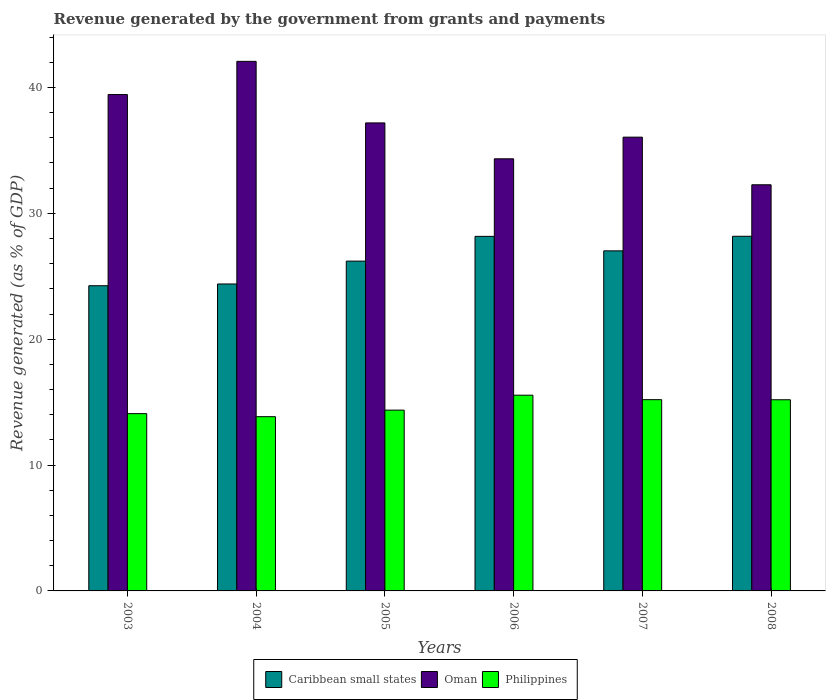How many groups of bars are there?
Offer a very short reply. 6. In how many cases, is the number of bars for a given year not equal to the number of legend labels?
Provide a short and direct response. 0. What is the revenue generated by the government in Philippines in 2003?
Your answer should be very brief. 14.09. Across all years, what is the maximum revenue generated by the government in Philippines?
Your response must be concise. 15.55. Across all years, what is the minimum revenue generated by the government in Philippines?
Ensure brevity in your answer.  13.84. What is the total revenue generated by the government in Philippines in the graph?
Your answer should be very brief. 88.23. What is the difference between the revenue generated by the government in Philippines in 2005 and that in 2008?
Give a very brief answer. -0.82. What is the difference between the revenue generated by the government in Oman in 2007 and the revenue generated by the government in Caribbean small states in 2004?
Offer a terse response. 11.67. What is the average revenue generated by the government in Oman per year?
Offer a terse response. 36.89. In the year 2006, what is the difference between the revenue generated by the government in Caribbean small states and revenue generated by the government in Philippines?
Offer a terse response. 12.62. In how many years, is the revenue generated by the government in Caribbean small states greater than 8 %?
Provide a succinct answer. 6. What is the ratio of the revenue generated by the government in Caribbean small states in 2004 to that in 2008?
Provide a short and direct response. 0.87. Is the revenue generated by the government in Philippines in 2003 less than that in 2008?
Make the answer very short. Yes. What is the difference between the highest and the second highest revenue generated by the government in Philippines?
Ensure brevity in your answer.  0.36. What is the difference between the highest and the lowest revenue generated by the government in Philippines?
Keep it short and to the point. 1.71. Is the sum of the revenue generated by the government in Philippines in 2005 and 2007 greater than the maximum revenue generated by the government in Oman across all years?
Your answer should be compact. No. What does the 1st bar from the left in 2006 represents?
Offer a very short reply. Caribbean small states. What does the 1st bar from the right in 2007 represents?
Provide a succinct answer. Philippines. How many bars are there?
Ensure brevity in your answer.  18. How many years are there in the graph?
Provide a succinct answer. 6. What is the difference between two consecutive major ticks on the Y-axis?
Ensure brevity in your answer.  10. Does the graph contain any zero values?
Offer a very short reply. No. Does the graph contain grids?
Provide a short and direct response. No. How many legend labels are there?
Give a very brief answer. 3. What is the title of the graph?
Your answer should be very brief. Revenue generated by the government from grants and payments. Does "Gambia, The" appear as one of the legend labels in the graph?
Your response must be concise. No. What is the label or title of the Y-axis?
Make the answer very short. Revenue generated (as % of GDP). What is the Revenue generated (as % of GDP) of Caribbean small states in 2003?
Your answer should be very brief. 24.25. What is the Revenue generated (as % of GDP) of Oman in 2003?
Your response must be concise. 39.44. What is the Revenue generated (as % of GDP) of Philippines in 2003?
Your response must be concise. 14.09. What is the Revenue generated (as % of GDP) in Caribbean small states in 2004?
Offer a terse response. 24.39. What is the Revenue generated (as % of GDP) of Oman in 2004?
Your answer should be compact. 42.07. What is the Revenue generated (as % of GDP) of Philippines in 2004?
Your answer should be compact. 13.84. What is the Revenue generated (as % of GDP) in Caribbean small states in 2005?
Keep it short and to the point. 26.2. What is the Revenue generated (as % of GDP) of Oman in 2005?
Make the answer very short. 37.18. What is the Revenue generated (as % of GDP) of Philippines in 2005?
Give a very brief answer. 14.36. What is the Revenue generated (as % of GDP) in Caribbean small states in 2006?
Make the answer very short. 28.17. What is the Revenue generated (as % of GDP) of Oman in 2006?
Give a very brief answer. 34.33. What is the Revenue generated (as % of GDP) of Philippines in 2006?
Your answer should be very brief. 15.55. What is the Revenue generated (as % of GDP) of Caribbean small states in 2007?
Give a very brief answer. 27.02. What is the Revenue generated (as % of GDP) in Oman in 2007?
Offer a terse response. 36.05. What is the Revenue generated (as % of GDP) in Philippines in 2007?
Make the answer very short. 15.2. What is the Revenue generated (as % of GDP) of Caribbean small states in 2008?
Provide a short and direct response. 28.18. What is the Revenue generated (as % of GDP) in Oman in 2008?
Offer a terse response. 32.27. What is the Revenue generated (as % of GDP) in Philippines in 2008?
Provide a short and direct response. 15.19. Across all years, what is the maximum Revenue generated (as % of GDP) of Caribbean small states?
Your response must be concise. 28.18. Across all years, what is the maximum Revenue generated (as % of GDP) in Oman?
Give a very brief answer. 42.07. Across all years, what is the maximum Revenue generated (as % of GDP) in Philippines?
Ensure brevity in your answer.  15.55. Across all years, what is the minimum Revenue generated (as % of GDP) of Caribbean small states?
Your answer should be compact. 24.25. Across all years, what is the minimum Revenue generated (as % of GDP) in Oman?
Keep it short and to the point. 32.27. Across all years, what is the minimum Revenue generated (as % of GDP) of Philippines?
Provide a short and direct response. 13.84. What is the total Revenue generated (as % of GDP) of Caribbean small states in the graph?
Your answer should be very brief. 158.21. What is the total Revenue generated (as % of GDP) in Oman in the graph?
Keep it short and to the point. 221.35. What is the total Revenue generated (as % of GDP) in Philippines in the graph?
Ensure brevity in your answer.  88.23. What is the difference between the Revenue generated (as % of GDP) of Caribbean small states in 2003 and that in 2004?
Provide a succinct answer. -0.14. What is the difference between the Revenue generated (as % of GDP) of Oman in 2003 and that in 2004?
Provide a succinct answer. -2.64. What is the difference between the Revenue generated (as % of GDP) of Philippines in 2003 and that in 2004?
Provide a short and direct response. 0.24. What is the difference between the Revenue generated (as % of GDP) in Caribbean small states in 2003 and that in 2005?
Provide a succinct answer. -1.96. What is the difference between the Revenue generated (as % of GDP) in Oman in 2003 and that in 2005?
Offer a very short reply. 2.25. What is the difference between the Revenue generated (as % of GDP) in Philippines in 2003 and that in 2005?
Provide a short and direct response. -0.28. What is the difference between the Revenue generated (as % of GDP) of Caribbean small states in 2003 and that in 2006?
Your answer should be very brief. -3.92. What is the difference between the Revenue generated (as % of GDP) in Oman in 2003 and that in 2006?
Your response must be concise. 5.11. What is the difference between the Revenue generated (as % of GDP) of Philippines in 2003 and that in 2006?
Ensure brevity in your answer.  -1.47. What is the difference between the Revenue generated (as % of GDP) in Caribbean small states in 2003 and that in 2007?
Offer a terse response. -2.77. What is the difference between the Revenue generated (as % of GDP) in Oman in 2003 and that in 2007?
Your answer should be very brief. 3.38. What is the difference between the Revenue generated (as % of GDP) of Philippines in 2003 and that in 2007?
Offer a terse response. -1.11. What is the difference between the Revenue generated (as % of GDP) of Caribbean small states in 2003 and that in 2008?
Keep it short and to the point. -3.93. What is the difference between the Revenue generated (as % of GDP) of Oman in 2003 and that in 2008?
Keep it short and to the point. 7.17. What is the difference between the Revenue generated (as % of GDP) in Philippines in 2003 and that in 2008?
Your response must be concise. -1.1. What is the difference between the Revenue generated (as % of GDP) of Caribbean small states in 2004 and that in 2005?
Provide a succinct answer. -1.82. What is the difference between the Revenue generated (as % of GDP) of Oman in 2004 and that in 2005?
Offer a very short reply. 4.89. What is the difference between the Revenue generated (as % of GDP) in Philippines in 2004 and that in 2005?
Provide a succinct answer. -0.52. What is the difference between the Revenue generated (as % of GDP) in Caribbean small states in 2004 and that in 2006?
Keep it short and to the point. -3.78. What is the difference between the Revenue generated (as % of GDP) of Oman in 2004 and that in 2006?
Keep it short and to the point. 7.74. What is the difference between the Revenue generated (as % of GDP) in Philippines in 2004 and that in 2006?
Keep it short and to the point. -1.71. What is the difference between the Revenue generated (as % of GDP) of Caribbean small states in 2004 and that in 2007?
Offer a very short reply. -2.63. What is the difference between the Revenue generated (as % of GDP) in Oman in 2004 and that in 2007?
Offer a very short reply. 6.02. What is the difference between the Revenue generated (as % of GDP) in Philippines in 2004 and that in 2007?
Offer a terse response. -1.35. What is the difference between the Revenue generated (as % of GDP) in Caribbean small states in 2004 and that in 2008?
Offer a very short reply. -3.79. What is the difference between the Revenue generated (as % of GDP) of Oman in 2004 and that in 2008?
Provide a short and direct response. 9.81. What is the difference between the Revenue generated (as % of GDP) in Philippines in 2004 and that in 2008?
Provide a short and direct response. -1.34. What is the difference between the Revenue generated (as % of GDP) of Caribbean small states in 2005 and that in 2006?
Give a very brief answer. -1.97. What is the difference between the Revenue generated (as % of GDP) in Oman in 2005 and that in 2006?
Give a very brief answer. 2.85. What is the difference between the Revenue generated (as % of GDP) in Philippines in 2005 and that in 2006?
Offer a very short reply. -1.19. What is the difference between the Revenue generated (as % of GDP) in Caribbean small states in 2005 and that in 2007?
Make the answer very short. -0.81. What is the difference between the Revenue generated (as % of GDP) in Oman in 2005 and that in 2007?
Your response must be concise. 1.13. What is the difference between the Revenue generated (as % of GDP) of Philippines in 2005 and that in 2007?
Offer a terse response. -0.83. What is the difference between the Revenue generated (as % of GDP) in Caribbean small states in 2005 and that in 2008?
Offer a very short reply. -1.97. What is the difference between the Revenue generated (as % of GDP) of Oman in 2005 and that in 2008?
Keep it short and to the point. 4.91. What is the difference between the Revenue generated (as % of GDP) in Philippines in 2005 and that in 2008?
Ensure brevity in your answer.  -0.82. What is the difference between the Revenue generated (as % of GDP) in Caribbean small states in 2006 and that in 2007?
Provide a short and direct response. 1.15. What is the difference between the Revenue generated (as % of GDP) of Oman in 2006 and that in 2007?
Your answer should be compact. -1.72. What is the difference between the Revenue generated (as % of GDP) in Philippines in 2006 and that in 2007?
Make the answer very short. 0.36. What is the difference between the Revenue generated (as % of GDP) in Caribbean small states in 2006 and that in 2008?
Make the answer very short. -0.01. What is the difference between the Revenue generated (as % of GDP) of Oman in 2006 and that in 2008?
Offer a terse response. 2.06. What is the difference between the Revenue generated (as % of GDP) of Philippines in 2006 and that in 2008?
Make the answer very short. 0.36. What is the difference between the Revenue generated (as % of GDP) of Caribbean small states in 2007 and that in 2008?
Ensure brevity in your answer.  -1.16. What is the difference between the Revenue generated (as % of GDP) in Oman in 2007 and that in 2008?
Your response must be concise. 3.78. What is the difference between the Revenue generated (as % of GDP) in Philippines in 2007 and that in 2008?
Provide a short and direct response. 0.01. What is the difference between the Revenue generated (as % of GDP) in Caribbean small states in 2003 and the Revenue generated (as % of GDP) in Oman in 2004?
Keep it short and to the point. -17.83. What is the difference between the Revenue generated (as % of GDP) in Caribbean small states in 2003 and the Revenue generated (as % of GDP) in Philippines in 2004?
Ensure brevity in your answer.  10.41. What is the difference between the Revenue generated (as % of GDP) in Oman in 2003 and the Revenue generated (as % of GDP) in Philippines in 2004?
Ensure brevity in your answer.  25.59. What is the difference between the Revenue generated (as % of GDP) in Caribbean small states in 2003 and the Revenue generated (as % of GDP) in Oman in 2005?
Offer a very short reply. -12.93. What is the difference between the Revenue generated (as % of GDP) in Caribbean small states in 2003 and the Revenue generated (as % of GDP) in Philippines in 2005?
Offer a terse response. 9.88. What is the difference between the Revenue generated (as % of GDP) in Oman in 2003 and the Revenue generated (as % of GDP) in Philippines in 2005?
Your answer should be very brief. 25.07. What is the difference between the Revenue generated (as % of GDP) in Caribbean small states in 2003 and the Revenue generated (as % of GDP) in Oman in 2006?
Your response must be concise. -10.08. What is the difference between the Revenue generated (as % of GDP) of Caribbean small states in 2003 and the Revenue generated (as % of GDP) of Philippines in 2006?
Ensure brevity in your answer.  8.7. What is the difference between the Revenue generated (as % of GDP) of Oman in 2003 and the Revenue generated (as % of GDP) of Philippines in 2006?
Your response must be concise. 23.89. What is the difference between the Revenue generated (as % of GDP) of Caribbean small states in 2003 and the Revenue generated (as % of GDP) of Oman in 2007?
Your response must be concise. -11.8. What is the difference between the Revenue generated (as % of GDP) of Caribbean small states in 2003 and the Revenue generated (as % of GDP) of Philippines in 2007?
Offer a terse response. 9.05. What is the difference between the Revenue generated (as % of GDP) in Oman in 2003 and the Revenue generated (as % of GDP) in Philippines in 2007?
Provide a short and direct response. 24.24. What is the difference between the Revenue generated (as % of GDP) of Caribbean small states in 2003 and the Revenue generated (as % of GDP) of Oman in 2008?
Keep it short and to the point. -8.02. What is the difference between the Revenue generated (as % of GDP) in Caribbean small states in 2003 and the Revenue generated (as % of GDP) in Philippines in 2008?
Make the answer very short. 9.06. What is the difference between the Revenue generated (as % of GDP) in Oman in 2003 and the Revenue generated (as % of GDP) in Philippines in 2008?
Provide a short and direct response. 24.25. What is the difference between the Revenue generated (as % of GDP) in Caribbean small states in 2004 and the Revenue generated (as % of GDP) in Oman in 2005?
Your answer should be compact. -12.8. What is the difference between the Revenue generated (as % of GDP) of Caribbean small states in 2004 and the Revenue generated (as % of GDP) of Philippines in 2005?
Your answer should be compact. 10.02. What is the difference between the Revenue generated (as % of GDP) of Oman in 2004 and the Revenue generated (as % of GDP) of Philippines in 2005?
Provide a succinct answer. 27.71. What is the difference between the Revenue generated (as % of GDP) in Caribbean small states in 2004 and the Revenue generated (as % of GDP) in Oman in 2006?
Keep it short and to the point. -9.94. What is the difference between the Revenue generated (as % of GDP) of Caribbean small states in 2004 and the Revenue generated (as % of GDP) of Philippines in 2006?
Ensure brevity in your answer.  8.84. What is the difference between the Revenue generated (as % of GDP) in Oman in 2004 and the Revenue generated (as % of GDP) in Philippines in 2006?
Give a very brief answer. 26.52. What is the difference between the Revenue generated (as % of GDP) in Caribbean small states in 2004 and the Revenue generated (as % of GDP) in Oman in 2007?
Keep it short and to the point. -11.67. What is the difference between the Revenue generated (as % of GDP) of Caribbean small states in 2004 and the Revenue generated (as % of GDP) of Philippines in 2007?
Your answer should be very brief. 9.19. What is the difference between the Revenue generated (as % of GDP) in Oman in 2004 and the Revenue generated (as % of GDP) in Philippines in 2007?
Ensure brevity in your answer.  26.88. What is the difference between the Revenue generated (as % of GDP) in Caribbean small states in 2004 and the Revenue generated (as % of GDP) in Oman in 2008?
Offer a terse response. -7.88. What is the difference between the Revenue generated (as % of GDP) of Oman in 2004 and the Revenue generated (as % of GDP) of Philippines in 2008?
Your answer should be very brief. 26.89. What is the difference between the Revenue generated (as % of GDP) of Caribbean small states in 2005 and the Revenue generated (as % of GDP) of Oman in 2006?
Offer a very short reply. -8.13. What is the difference between the Revenue generated (as % of GDP) in Caribbean small states in 2005 and the Revenue generated (as % of GDP) in Philippines in 2006?
Your answer should be compact. 10.65. What is the difference between the Revenue generated (as % of GDP) in Oman in 2005 and the Revenue generated (as % of GDP) in Philippines in 2006?
Offer a very short reply. 21.63. What is the difference between the Revenue generated (as % of GDP) of Caribbean small states in 2005 and the Revenue generated (as % of GDP) of Oman in 2007?
Ensure brevity in your answer.  -9.85. What is the difference between the Revenue generated (as % of GDP) in Caribbean small states in 2005 and the Revenue generated (as % of GDP) in Philippines in 2007?
Make the answer very short. 11.01. What is the difference between the Revenue generated (as % of GDP) in Oman in 2005 and the Revenue generated (as % of GDP) in Philippines in 2007?
Provide a short and direct response. 21.99. What is the difference between the Revenue generated (as % of GDP) of Caribbean small states in 2005 and the Revenue generated (as % of GDP) of Oman in 2008?
Offer a very short reply. -6.07. What is the difference between the Revenue generated (as % of GDP) in Caribbean small states in 2005 and the Revenue generated (as % of GDP) in Philippines in 2008?
Ensure brevity in your answer.  11.02. What is the difference between the Revenue generated (as % of GDP) in Oman in 2005 and the Revenue generated (as % of GDP) in Philippines in 2008?
Provide a succinct answer. 22. What is the difference between the Revenue generated (as % of GDP) in Caribbean small states in 2006 and the Revenue generated (as % of GDP) in Oman in 2007?
Your response must be concise. -7.88. What is the difference between the Revenue generated (as % of GDP) of Caribbean small states in 2006 and the Revenue generated (as % of GDP) of Philippines in 2007?
Ensure brevity in your answer.  12.98. What is the difference between the Revenue generated (as % of GDP) of Oman in 2006 and the Revenue generated (as % of GDP) of Philippines in 2007?
Provide a succinct answer. 19.14. What is the difference between the Revenue generated (as % of GDP) of Caribbean small states in 2006 and the Revenue generated (as % of GDP) of Oman in 2008?
Ensure brevity in your answer.  -4.1. What is the difference between the Revenue generated (as % of GDP) of Caribbean small states in 2006 and the Revenue generated (as % of GDP) of Philippines in 2008?
Offer a very short reply. 12.98. What is the difference between the Revenue generated (as % of GDP) in Oman in 2006 and the Revenue generated (as % of GDP) in Philippines in 2008?
Keep it short and to the point. 19.14. What is the difference between the Revenue generated (as % of GDP) in Caribbean small states in 2007 and the Revenue generated (as % of GDP) in Oman in 2008?
Your answer should be compact. -5.25. What is the difference between the Revenue generated (as % of GDP) in Caribbean small states in 2007 and the Revenue generated (as % of GDP) in Philippines in 2008?
Your answer should be compact. 11.83. What is the difference between the Revenue generated (as % of GDP) in Oman in 2007 and the Revenue generated (as % of GDP) in Philippines in 2008?
Provide a succinct answer. 20.87. What is the average Revenue generated (as % of GDP) of Caribbean small states per year?
Your answer should be compact. 26.37. What is the average Revenue generated (as % of GDP) in Oman per year?
Your response must be concise. 36.89. What is the average Revenue generated (as % of GDP) in Philippines per year?
Keep it short and to the point. 14.7. In the year 2003, what is the difference between the Revenue generated (as % of GDP) in Caribbean small states and Revenue generated (as % of GDP) in Oman?
Your response must be concise. -15.19. In the year 2003, what is the difference between the Revenue generated (as % of GDP) of Caribbean small states and Revenue generated (as % of GDP) of Philippines?
Your answer should be very brief. 10.16. In the year 2003, what is the difference between the Revenue generated (as % of GDP) of Oman and Revenue generated (as % of GDP) of Philippines?
Provide a short and direct response. 25.35. In the year 2004, what is the difference between the Revenue generated (as % of GDP) of Caribbean small states and Revenue generated (as % of GDP) of Oman?
Keep it short and to the point. -17.69. In the year 2004, what is the difference between the Revenue generated (as % of GDP) of Caribbean small states and Revenue generated (as % of GDP) of Philippines?
Offer a very short reply. 10.54. In the year 2004, what is the difference between the Revenue generated (as % of GDP) of Oman and Revenue generated (as % of GDP) of Philippines?
Your response must be concise. 28.23. In the year 2005, what is the difference between the Revenue generated (as % of GDP) in Caribbean small states and Revenue generated (as % of GDP) in Oman?
Give a very brief answer. -10.98. In the year 2005, what is the difference between the Revenue generated (as % of GDP) of Caribbean small states and Revenue generated (as % of GDP) of Philippines?
Keep it short and to the point. 11.84. In the year 2005, what is the difference between the Revenue generated (as % of GDP) in Oman and Revenue generated (as % of GDP) in Philippines?
Your answer should be compact. 22.82. In the year 2006, what is the difference between the Revenue generated (as % of GDP) in Caribbean small states and Revenue generated (as % of GDP) in Oman?
Your answer should be compact. -6.16. In the year 2006, what is the difference between the Revenue generated (as % of GDP) of Caribbean small states and Revenue generated (as % of GDP) of Philippines?
Ensure brevity in your answer.  12.62. In the year 2006, what is the difference between the Revenue generated (as % of GDP) in Oman and Revenue generated (as % of GDP) in Philippines?
Your answer should be very brief. 18.78. In the year 2007, what is the difference between the Revenue generated (as % of GDP) in Caribbean small states and Revenue generated (as % of GDP) in Oman?
Keep it short and to the point. -9.03. In the year 2007, what is the difference between the Revenue generated (as % of GDP) of Caribbean small states and Revenue generated (as % of GDP) of Philippines?
Make the answer very short. 11.82. In the year 2007, what is the difference between the Revenue generated (as % of GDP) of Oman and Revenue generated (as % of GDP) of Philippines?
Offer a terse response. 20.86. In the year 2008, what is the difference between the Revenue generated (as % of GDP) of Caribbean small states and Revenue generated (as % of GDP) of Oman?
Provide a short and direct response. -4.09. In the year 2008, what is the difference between the Revenue generated (as % of GDP) in Caribbean small states and Revenue generated (as % of GDP) in Philippines?
Your answer should be very brief. 12.99. In the year 2008, what is the difference between the Revenue generated (as % of GDP) in Oman and Revenue generated (as % of GDP) in Philippines?
Make the answer very short. 17.08. What is the ratio of the Revenue generated (as % of GDP) in Caribbean small states in 2003 to that in 2004?
Your response must be concise. 0.99. What is the ratio of the Revenue generated (as % of GDP) of Oman in 2003 to that in 2004?
Make the answer very short. 0.94. What is the ratio of the Revenue generated (as % of GDP) in Philippines in 2003 to that in 2004?
Provide a short and direct response. 1.02. What is the ratio of the Revenue generated (as % of GDP) in Caribbean small states in 2003 to that in 2005?
Your response must be concise. 0.93. What is the ratio of the Revenue generated (as % of GDP) in Oman in 2003 to that in 2005?
Give a very brief answer. 1.06. What is the ratio of the Revenue generated (as % of GDP) of Philippines in 2003 to that in 2005?
Provide a short and direct response. 0.98. What is the ratio of the Revenue generated (as % of GDP) in Caribbean small states in 2003 to that in 2006?
Make the answer very short. 0.86. What is the ratio of the Revenue generated (as % of GDP) of Oman in 2003 to that in 2006?
Your response must be concise. 1.15. What is the ratio of the Revenue generated (as % of GDP) of Philippines in 2003 to that in 2006?
Offer a very short reply. 0.91. What is the ratio of the Revenue generated (as % of GDP) in Caribbean small states in 2003 to that in 2007?
Offer a terse response. 0.9. What is the ratio of the Revenue generated (as % of GDP) of Oman in 2003 to that in 2007?
Keep it short and to the point. 1.09. What is the ratio of the Revenue generated (as % of GDP) of Philippines in 2003 to that in 2007?
Your answer should be very brief. 0.93. What is the ratio of the Revenue generated (as % of GDP) in Caribbean small states in 2003 to that in 2008?
Your response must be concise. 0.86. What is the ratio of the Revenue generated (as % of GDP) of Oman in 2003 to that in 2008?
Your answer should be compact. 1.22. What is the ratio of the Revenue generated (as % of GDP) of Philippines in 2003 to that in 2008?
Provide a succinct answer. 0.93. What is the ratio of the Revenue generated (as % of GDP) in Caribbean small states in 2004 to that in 2005?
Ensure brevity in your answer.  0.93. What is the ratio of the Revenue generated (as % of GDP) in Oman in 2004 to that in 2005?
Give a very brief answer. 1.13. What is the ratio of the Revenue generated (as % of GDP) of Philippines in 2004 to that in 2005?
Make the answer very short. 0.96. What is the ratio of the Revenue generated (as % of GDP) in Caribbean small states in 2004 to that in 2006?
Ensure brevity in your answer.  0.87. What is the ratio of the Revenue generated (as % of GDP) in Oman in 2004 to that in 2006?
Give a very brief answer. 1.23. What is the ratio of the Revenue generated (as % of GDP) of Philippines in 2004 to that in 2006?
Make the answer very short. 0.89. What is the ratio of the Revenue generated (as % of GDP) of Caribbean small states in 2004 to that in 2007?
Provide a succinct answer. 0.9. What is the ratio of the Revenue generated (as % of GDP) of Oman in 2004 to that in 2007?
Offer a terse response. 1.17. What is the ratio of the Revenue generated (as % of GDP) of Philippines in 2004 to that in 2007?
Keep it short and to the point. 0.91. What is the ratio of the Revenue generated (as % of GDP) of Caribbean small states in 2004 to that in 2008?
Your answer should be very brief. 0.87. What is the ratio of the Revenue generated (as % of GDP) in Oman in 2004 to that in 2008?
Keep it short and to the point. 1.3. What is the ratio of the Revenue generated (as % of GDP) in Philippines in 2004 to that in 2008?
Ensure brevity in your answer.  0.91. What is the ratio of the Revenue generated (as % of GDP) in Caribbean small states in 2005 to that in 2006?
Offer a very short reply. 0.93. What is the ratio of the Revenue generated (as % of GDP) of Oman in 2005 to that in 2006?
Provide a short and direct response. 1.08. What is the ratio of the Revenue generated (as % of GDP) in Philippines in 2005 to that in 2006?
Provide a succinct answer. 0.92. What is the ratio of the Revenue generated (as % of GDP) of Caribbean small states in 2005 to that in 2007?
Keep it short and to the point. 0.97. What is the ratio of the Revenue generated (as % of GDP) of Oman in 2005 to that in 2007?
Give a very brief answer. 1.03. What is the ratio of the Revenue generated (as % of GDP) of Philippines in 2005 to that in 2007?
Provide a succinct answer. 0.95. What is the ratio of the Revenue generated (as % of GDP) of Oman in 2005 to that in 2008?
Make the answer very short. 1.15. What is the ratio of the Revenue generated (as % of GDP) in Philippines in 2005 to that in 2008?
Offer a very short reply. 0.95. What is the ratio of the Revenue generated (as % of GDP) in Caribbean small states in 2006 to that in 2007?
Make the answer very short. 1.04. What is the ratio of the Revenue generated (as % of GDP) of Oman in 2006 to that in 2007?
Offer a very short reply. 0.95. What is the ratio of the Revenue generated (as % of GDP) of Philippines in 2006 to that in 2007?
Keep it short and to the point. 1.02. What is the ratio of the Revenue generated (as % of GDP) of Caribbean small states in 2006 to that in 2008?
Keep it short and to the point. 1. What is the ratio of the Revenue generated (as % of GDP) in Oman in 2006 to that in 2008?
Offer a terse response. 1.06. What is the ratio of the Revenue generated (as % of GDP) in Philippines in 2006 to that in 2008?
Keep it short and to the point. 1.02. What is the ratio of the Revenue generated (as % of GDP) in Caribbean small states in 2007 to that in 2008?
Provide a succinct answer. 0.96. What is the ratio of the Revenue generated (as % of GDP) in Oman in 2007 to that in 2008?
Offer a terse response. 1.12. What is the difference between the highest and the second highest Revenue generated (as % of GDP) in Caribbean small states?
Give a very brief answer. 0.01. What is the difference between the highest and the second highest Revenue generated (as % of GDP) of Oman?
Your answer should be very brief. 2.64. What is the difference between the highest and the second highest Revenue generated (as % of GDP) in Philippines?
Your answer should be very brief. 0.36. What is the difference between the highest and the lowest Revenue generated (as % of GDP) in Caribbean small states?
Offer a very short reply. 3.93. What is the difference between the highest and the lowest Revenue generated (as % of GDP) of Oman?
Your answer should be very brief. 9.81. What is the difference between the highest and the lowest Revenue generated (as % of GDP) in Philippines?
Give a very brief answer. 1.71. 